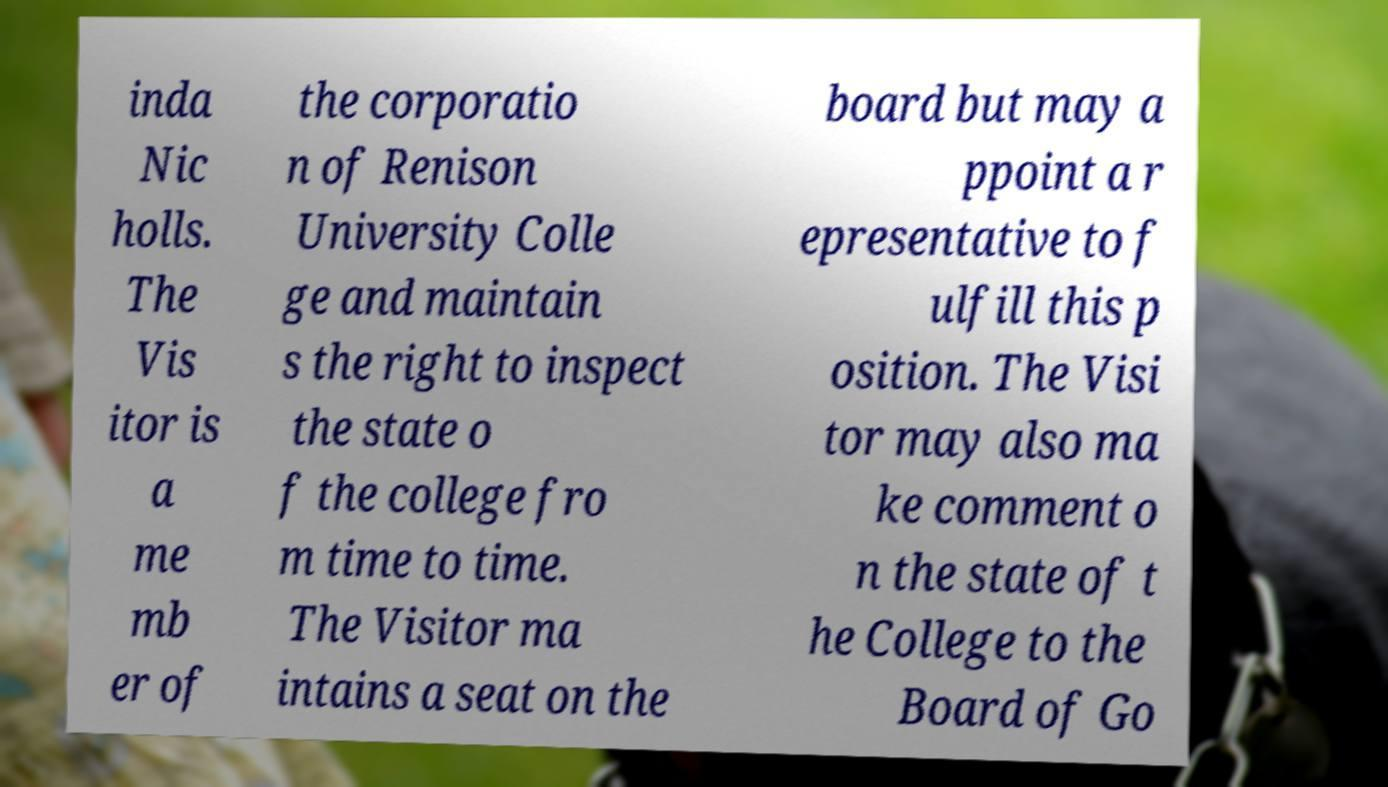Could you extract and type out the text from this image? inda Nic holls. The Vis itor is a me mb er of the corporatio n of Renison University Colle ge and maintain s the right to inspect the state o f the college fro m time to time. The Visitor ma intains a seat on the board but may a ppoint a r epresentative to f ulfill this p osition. The Visi tor may also ma ke comment o n the state of t he College to the Board of Go 